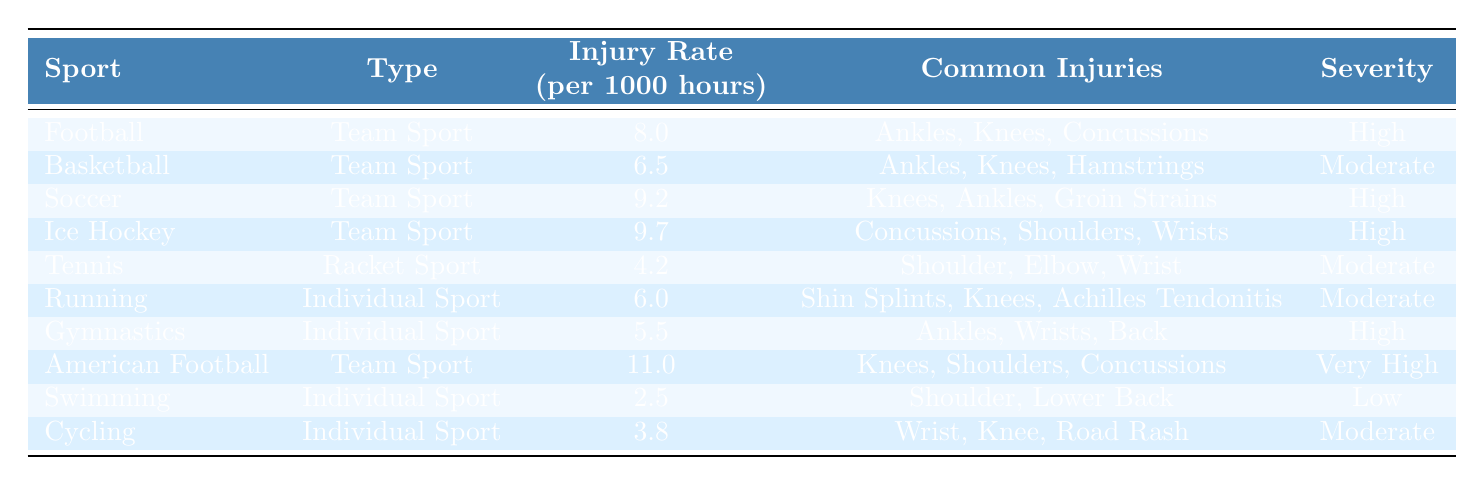What sport has the highest injury rate? Looking at the "Injury Rate (per 1000 hours)" column, American Football has the highest rate of 11.0.
Answer: American Football Which sport has the lowest injury rate? From the same column, Swimming has the lowest injury rate at 2.5.
Answer: Swimming True or false: Basketball has a higher injury rate than Running. Basketball's injury rate is 6.5, while Running's is 6.0, making the statement true.
Answer: True How many sports have a high or very high severity of injury? The "Severity" column shows that Football, Soccer, Ice Hockey, Gymnastics, and American Football have "High" or "Very High" severity, totaling five sports.
Answer: 5 What is the average injury rate for individual sports? The injury rates for individual sports are 4.2 (Tennis), 6.0 (Running), 5.5 (Gymnastics), 2.5 (Swimming), and 3.8 (Cycling). Their total is 22.0, and there are 5 sports, so the average is 22.0/5 = 4.4.
Answer: 4.4 Which common injuries are associated with Soccer? According to the "Common Injuries" column for Soccer, the common injuries are Knees, Ankles, and Groin Strains.
Answer: Knees, Ankles, Groin Strains What is the total injury rate for Team Sports? Total injury rates for Team Sports are 8.0 (Football) + 6.5 (Basketball) + 9.2 (Soccer) + 9.7 (Ice Hockey) + 11.0 (American Football) = 44.4, and there are 5 Team Sports, resulting in an average of 44.4/5 = 8.88.
Answer: 8.88 Are the common injuries for Tennis more severe than those for Swimming? The common injuries for Tennis are Shoulder, Elbow, and Wrist which have a Moderate severity, while Swimming's common injuries are Shoulder and Lower Back, which are classified as Low severity. Hence, Tennis's common injuries are more severe.
Answer: Yes Which two sports share the most common injuries? Reviewing the "Common Injuries" for multiple sports, both Football and Basketball list Ankles and Knees as common injuries, indicating they share those injuries.
Answer: Football and Basketball Is there any sport with a severity rating of low? The severity rating for Swimming is classified as Low, confirming the existence of such a sport.
Answer: Yes 